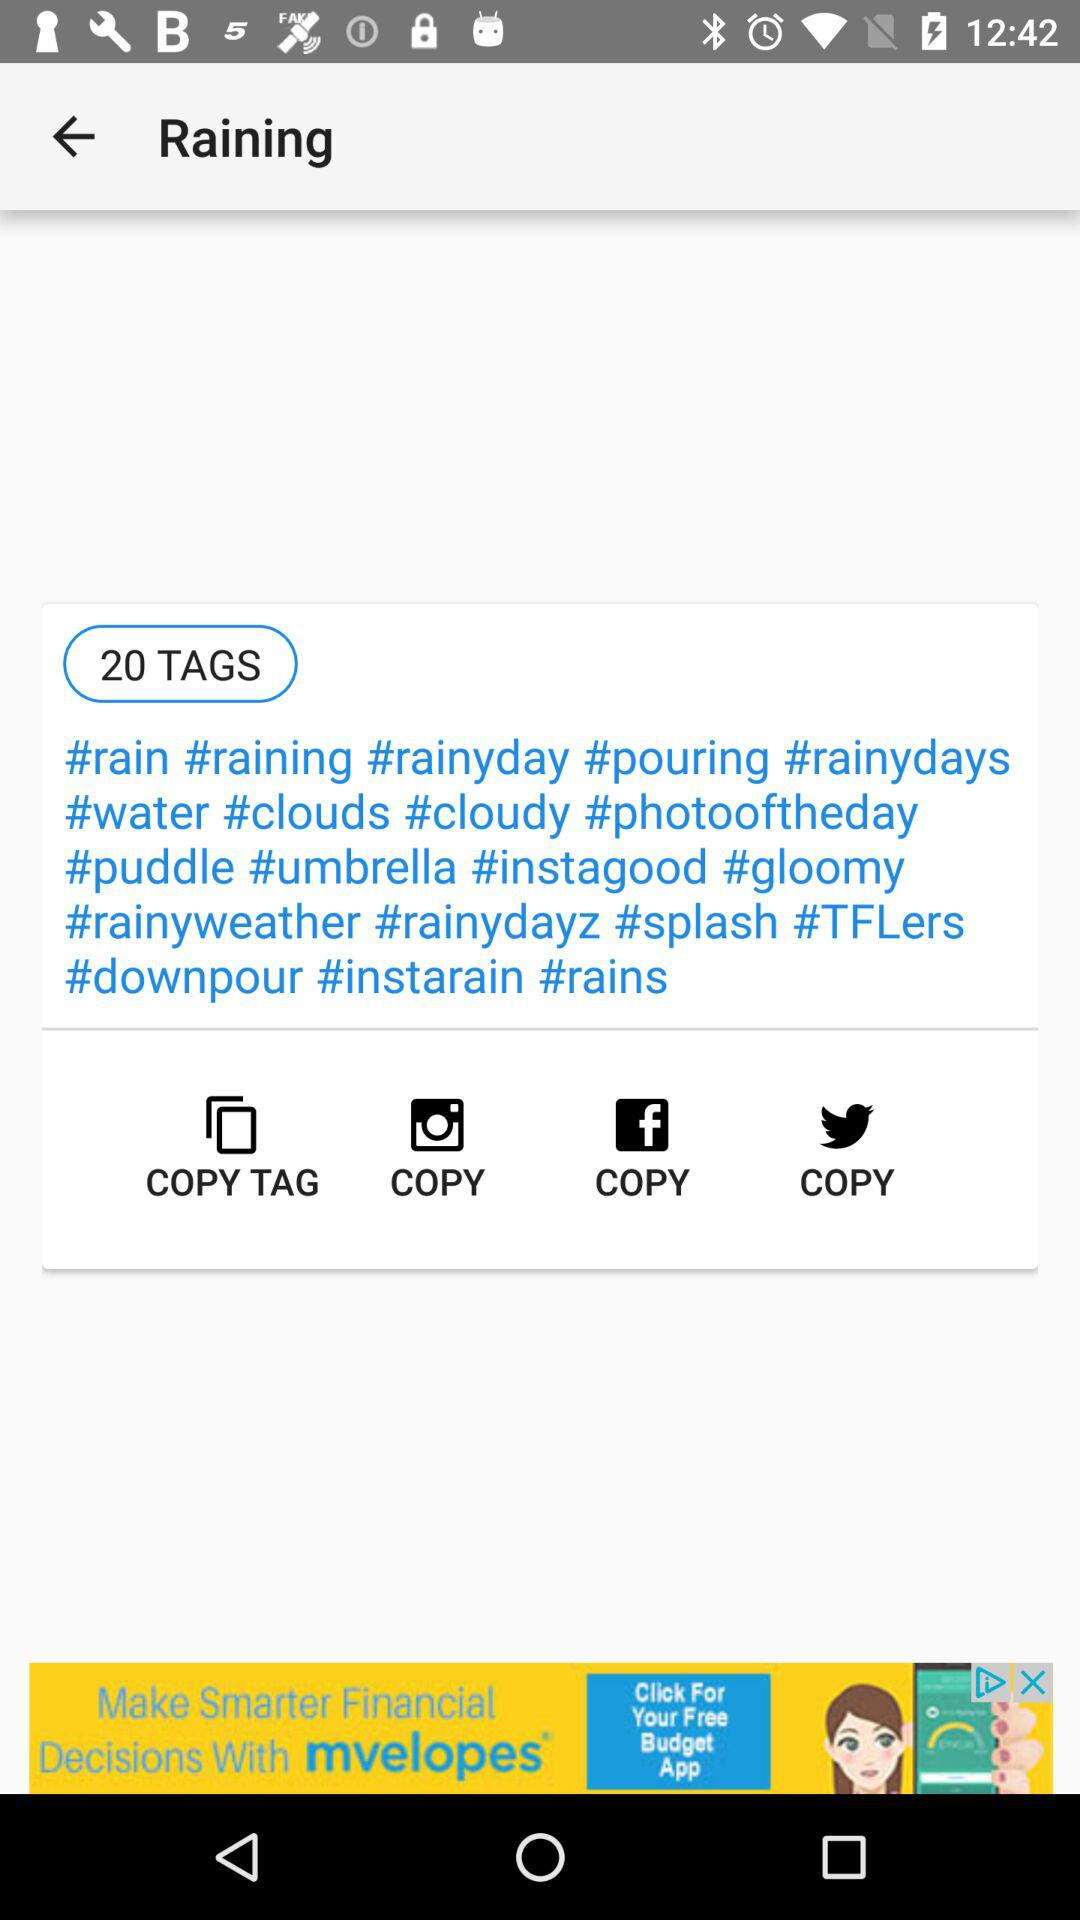How many tags in total are there? There are 20 tags in total. 